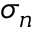Convert formula to latex. <formula><loc_0><loc_0><loc_500><loc_500>\sigma _ { n }</formula> 